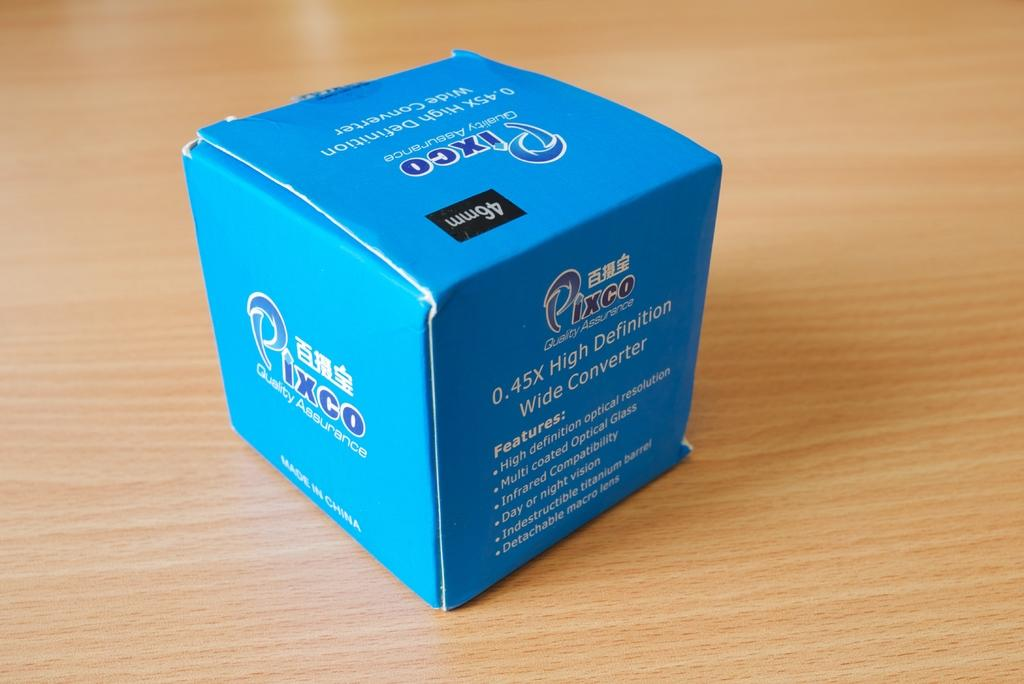What is the color of the box in the image? The box is blue in color. What can be seen on the surface of the box? There is something written on the box. What is the color of the surface on which the box is placed? The surface is brown. What song is being played from the box in the image? There is no indication in the image that the box is playing a song or has any musical capabilities. 